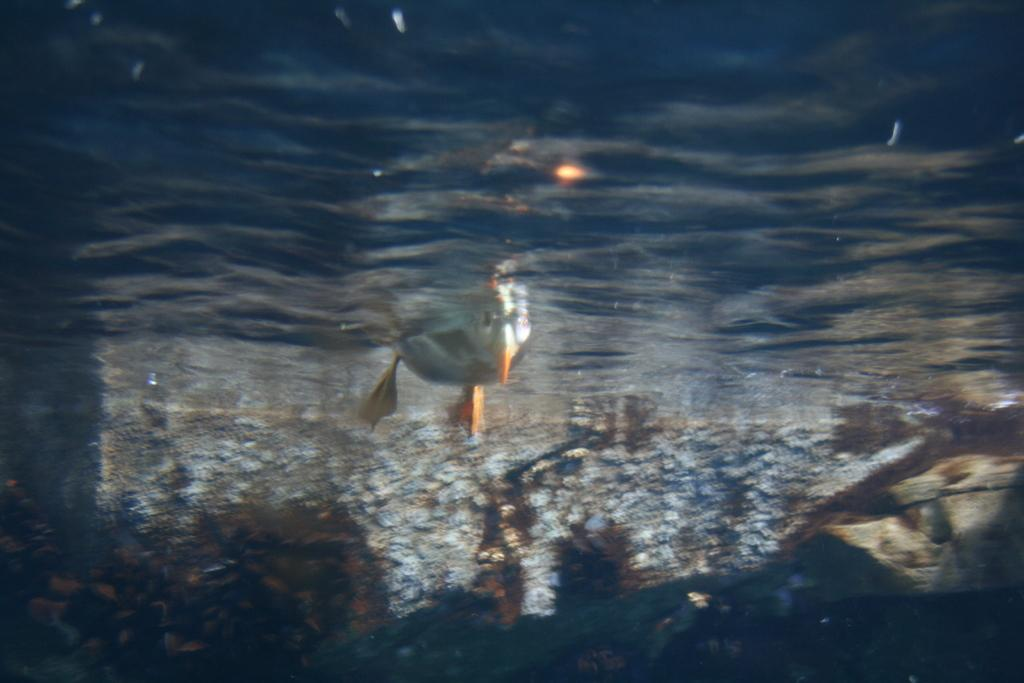What type of animal can be seen in the water in the image? There is a duck inside the water in the image. How many pizzas can be seen floating in the water in the image? There are no pizzas present in the image; it features a duck inside the water. Is there a competition taking place between the duck and another animal in the image? There is no competition depicted in the image; it simply shows a duck inside the water. Can you identify a friend of the duck in the image? There is no friend of the duck visible in the image; it only shows the duck inside the water. 